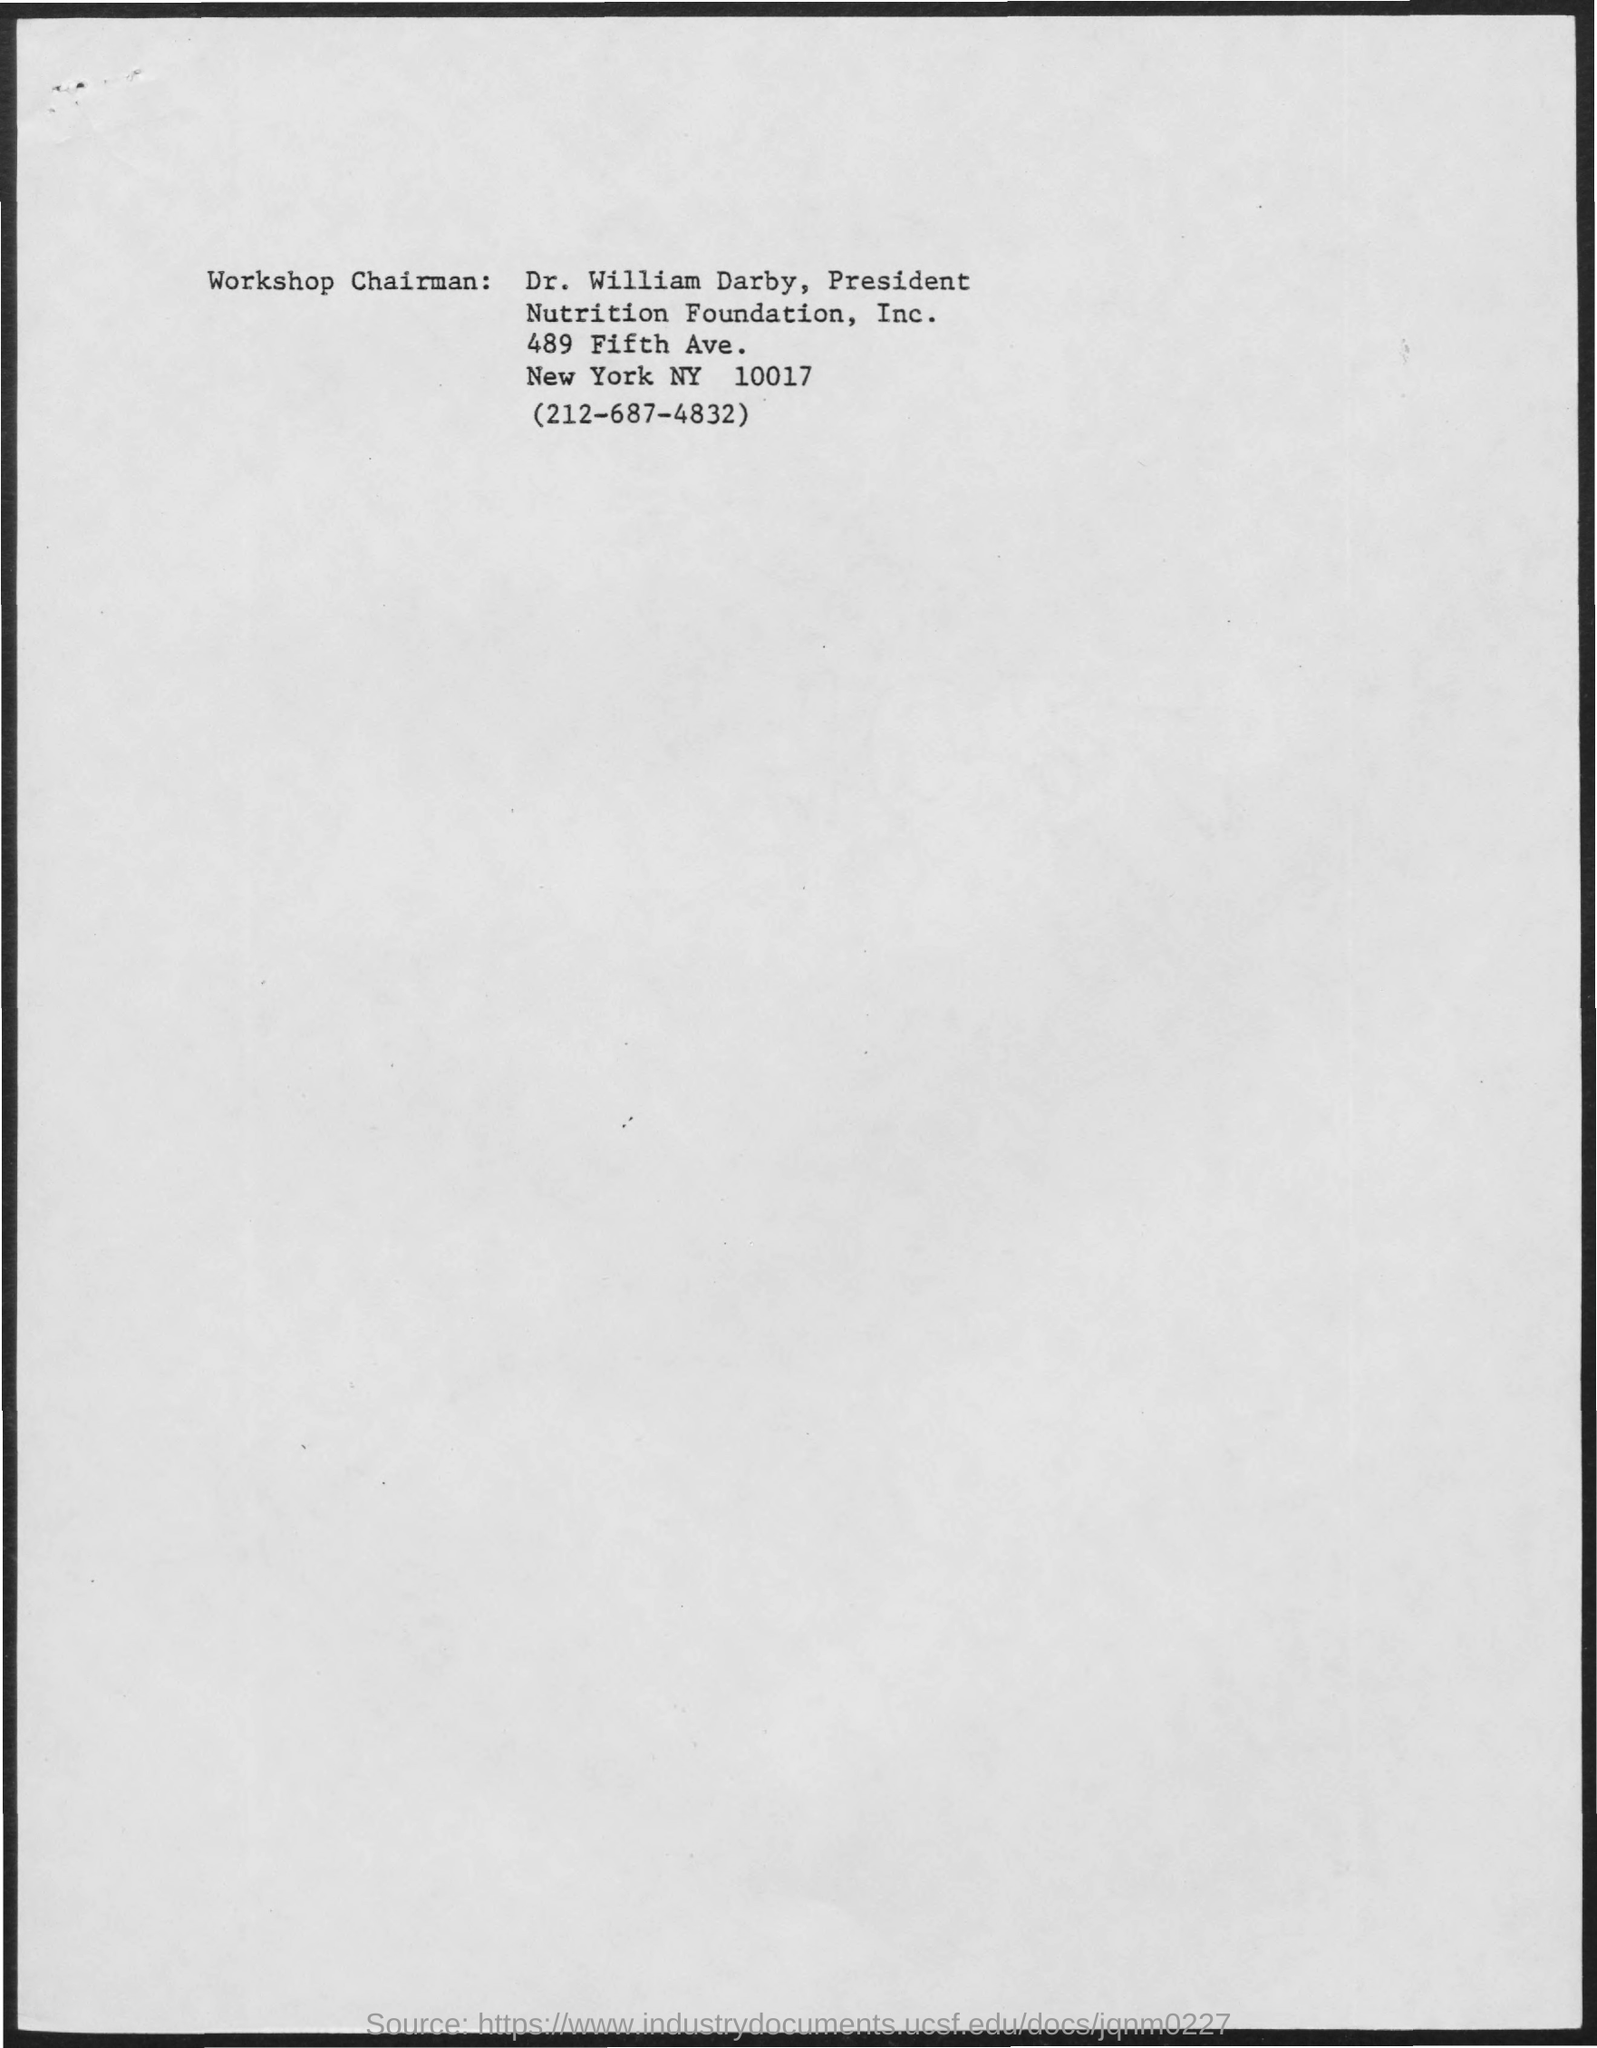What is the name of the workshop chairman mentioned ?
Make the answer very short. Dr. William Darby. 